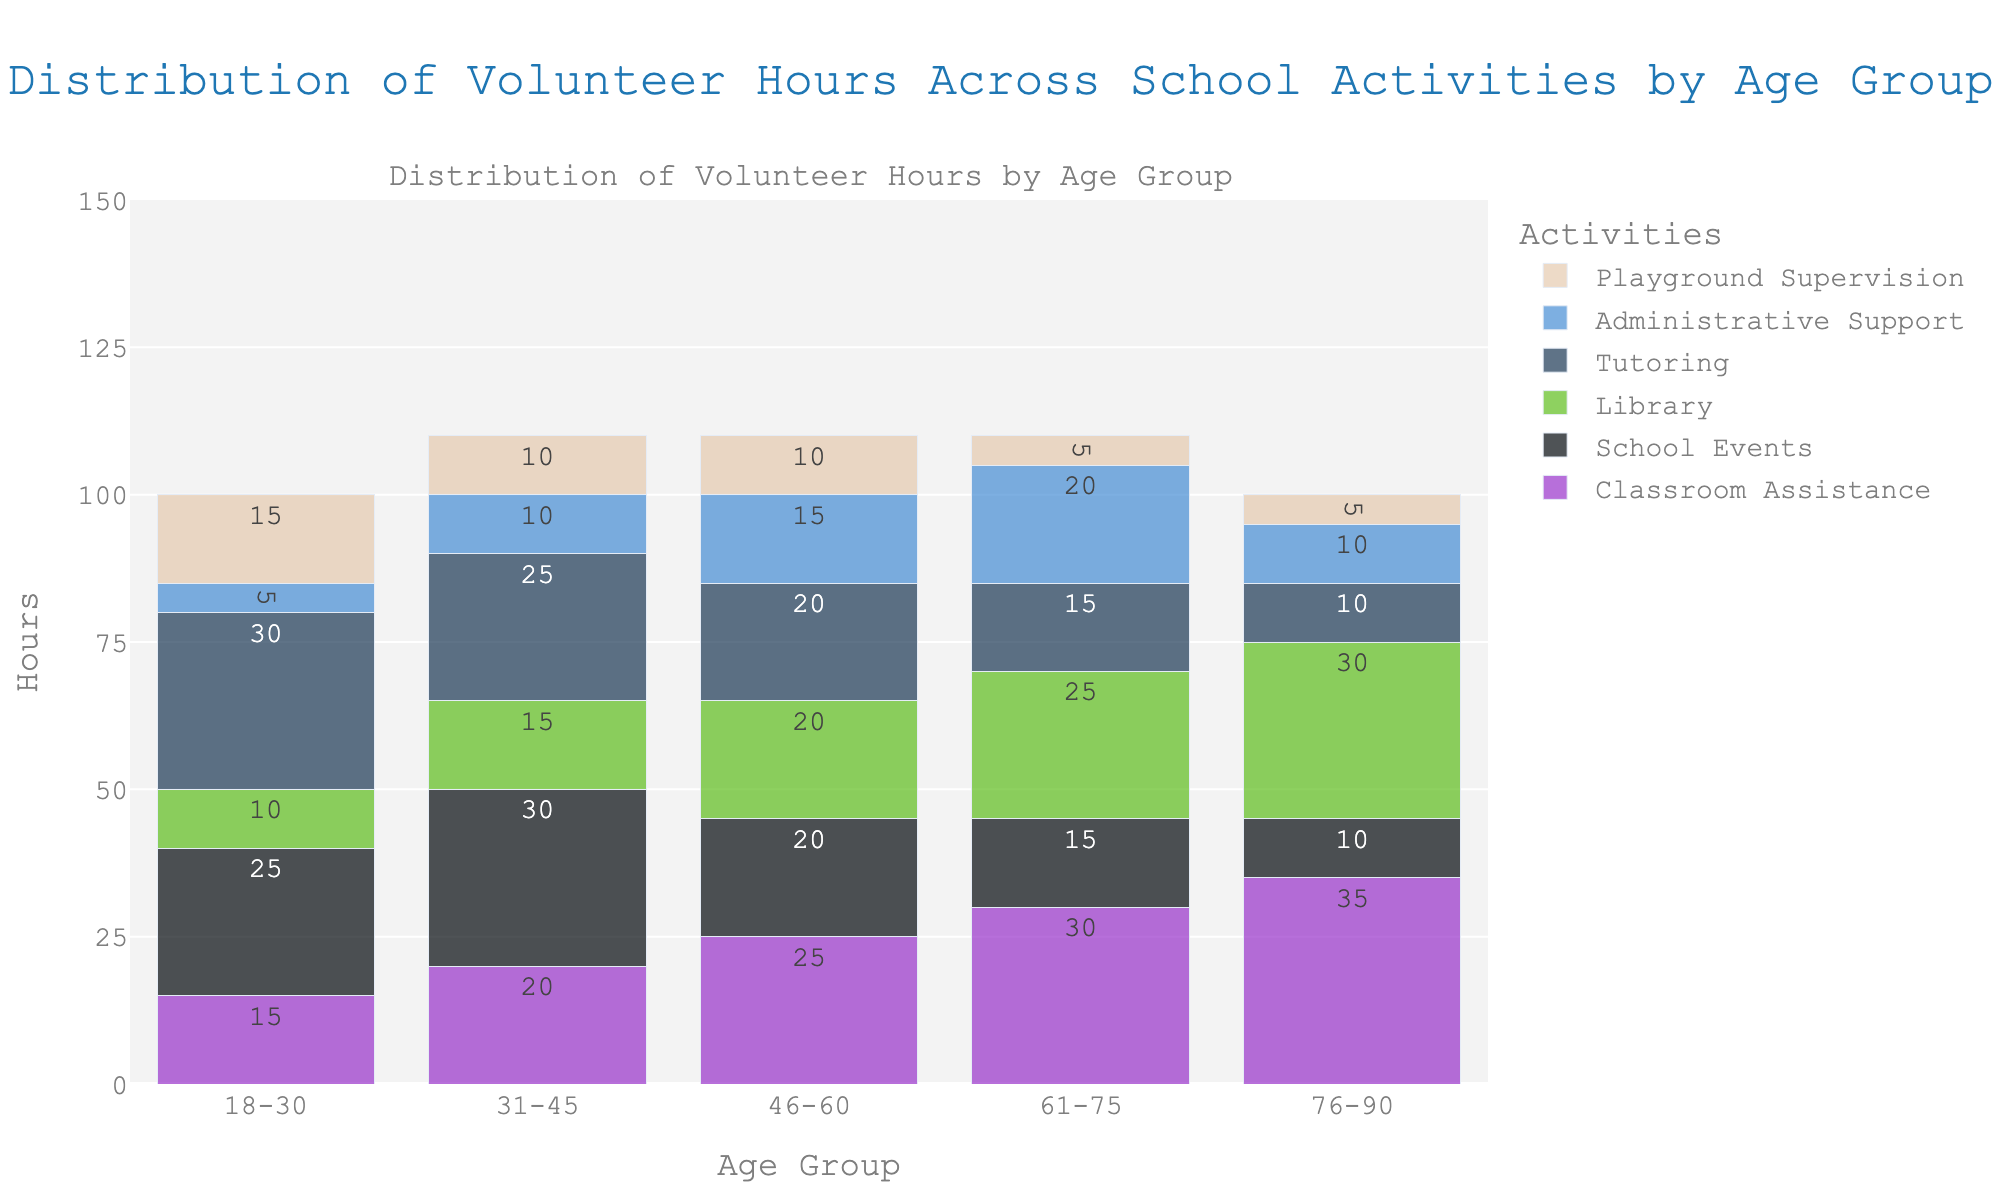Which age group volunteered the most hours in Classroom Assistance? To find the age group with the most hours in Classroom Assistance, look at the heights of the bars representing Classroom Assistance across all age groups. The bar for the age group 76-90 is highest, representing 35 hours.
Answer: 76-90 How many total hours were volunteered by the 31-45 age group across all activities? Sum the heights of all bars for the 31-45 age group across Classroom Assistance, School Events, Library, Tutoring, Administrative Support, and Playground Supervision (20 + 30 + 15 + 25 + 10 + 10). This equals 110 hours.
Answer: 110 Which activity had the least hours volunteered by the 46-60 age group? Look at the bars for all activities within the 46-60 age group to find the shortest bar. The shortest bars are for Playground Supervision, representing 10 hours.
Answer: Playground Supervision Which age group contributed more hours to Library activities, 18-30 or 46-60? Compare the heights of the bars representing Library activities for the 18-30 and 46-60 age groups. The bar for the 46-60 age group is taller, showing 20 hours compared to 10 hours for the 18-30 age group.
Answer: 46-60 What is the average number of volunteer hours spent on Tutoring across all age groups? Sum the hours for Tutoring across all age groups (30 + 25 + 20 + 15 + 10) to get 100. Divide by the number of age groups (5). The average is 100/5 = 20.
Answer: 20 Between the age groups 61-75 and 76-90, which one volunteered more hours in School Events? Compare the heights of the bars representing School Events for the age groups 61-75 and 76-90. The bar for the 61-75 age group shows 15 hours versus 10 hours for the 76-90 age group.
Answer: 61-75 Which age group shows a decreasing trend in hours volunteered from Classroom Assistance to Playground Supervision? Identify the bars for Classroom Assistance to Playground Supervision for each age group and note the trend. The 76-90 age group shows a decrease from 35 hours in Classroom Assistance down to 5 hours in Playground Supervision.
Answer: 76-90 By how much do the hours volunteered by the 61-75 age group in Classroom Assistance exceed those in Library activities? Find the hours for the 61-75 age group in Classroom Assistance and Library (30 and 25 respectively). Subtract the Library hours from Classroom Assistance hours: 30 - 25 = 5 hours.
Answer: 5 